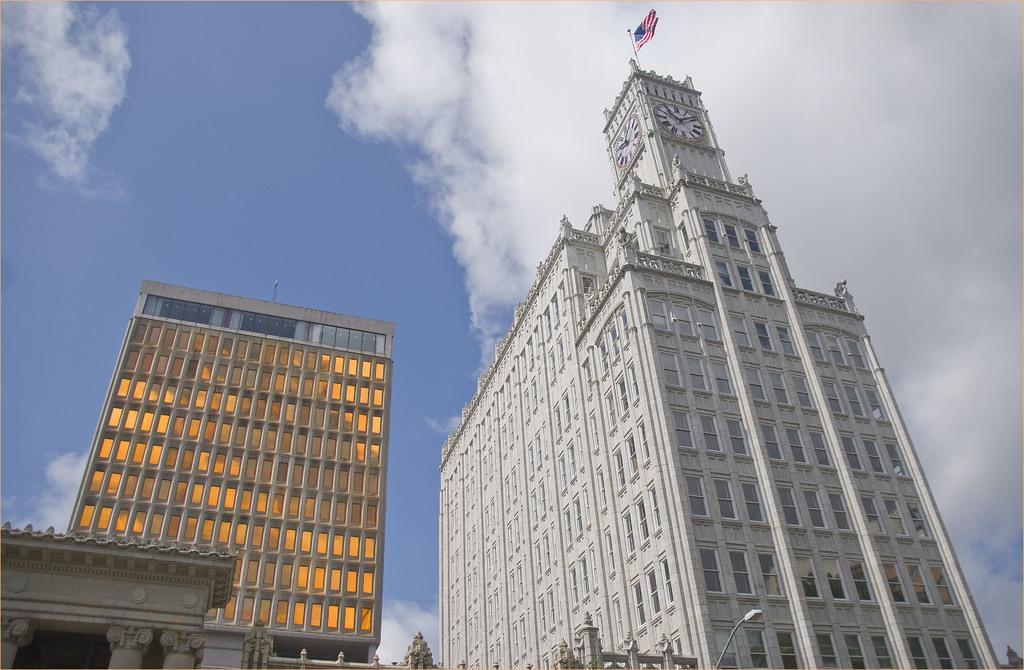Please provide a concise description of this image. In this picture I can see few buildings, where I can see 2 clocks and a flag on the white building. On the bottom side of this picture I can see a light pole. In the background I can see the sky which is a bit cloudy. 